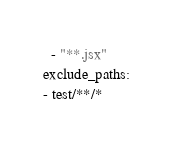<code> <loc_0><loc_0><loc_500><loc_500><_YAML_>  - "**.jsx"
exclude_paths:
- test/**/*
</code> 